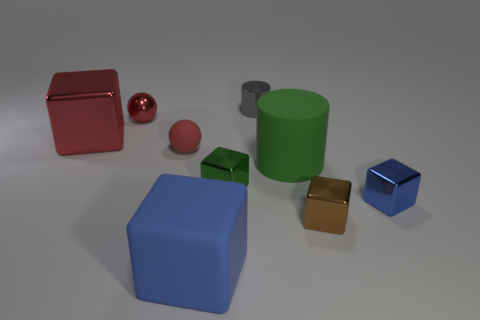Subtract all red cubes. How many cubes are left? 4 Subtract all tiny blue cubes. How many cubes are left? 4 Subtract all yellow blocks. Subtract all purple balls. How many blocks are left? 5 Add 1 big cyan cylinders. How many objects exist? 10 Subtract all spheres. How many objects are left? 7 Add 5 big cylinders. How many big cylinders exist? 6 Subtract 1 green cylinders. How many objects are left? 8 Subtract all big brown cubes. Subtract all brown blocks. How many objects are left? 8 Add 9 big cylinders. How many big cylinders are left? 10 